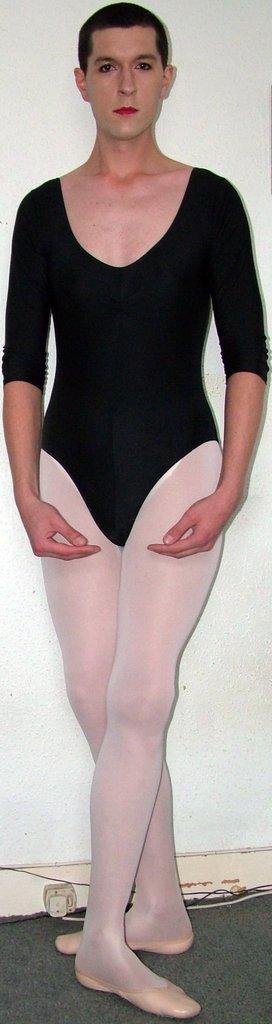How would you summarize this image in a sentence or two? In this image I can see a person is standing on the floor. In the background I can see a wall off white in color. This image is taken in a room. 